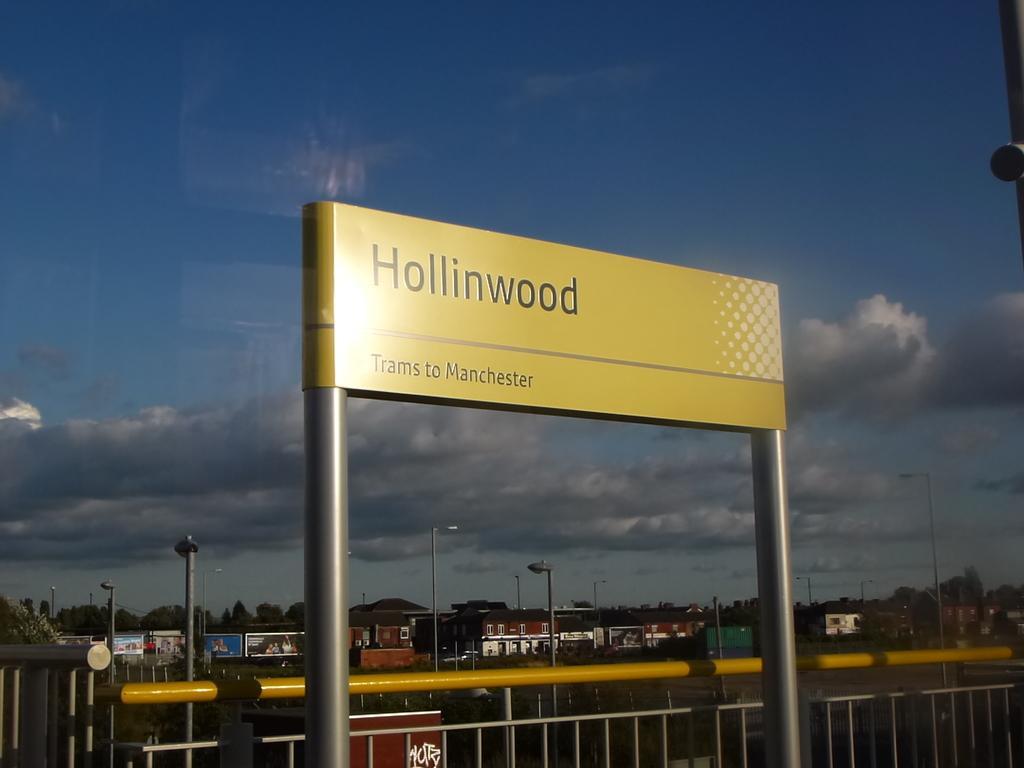Describe this image in one or two sentences. In this image I can see a yellow colour board and on it I can see something is written. In the background I can see number of poles, street lights, railings, trees, buildings and I can see sky and clouds in background. 